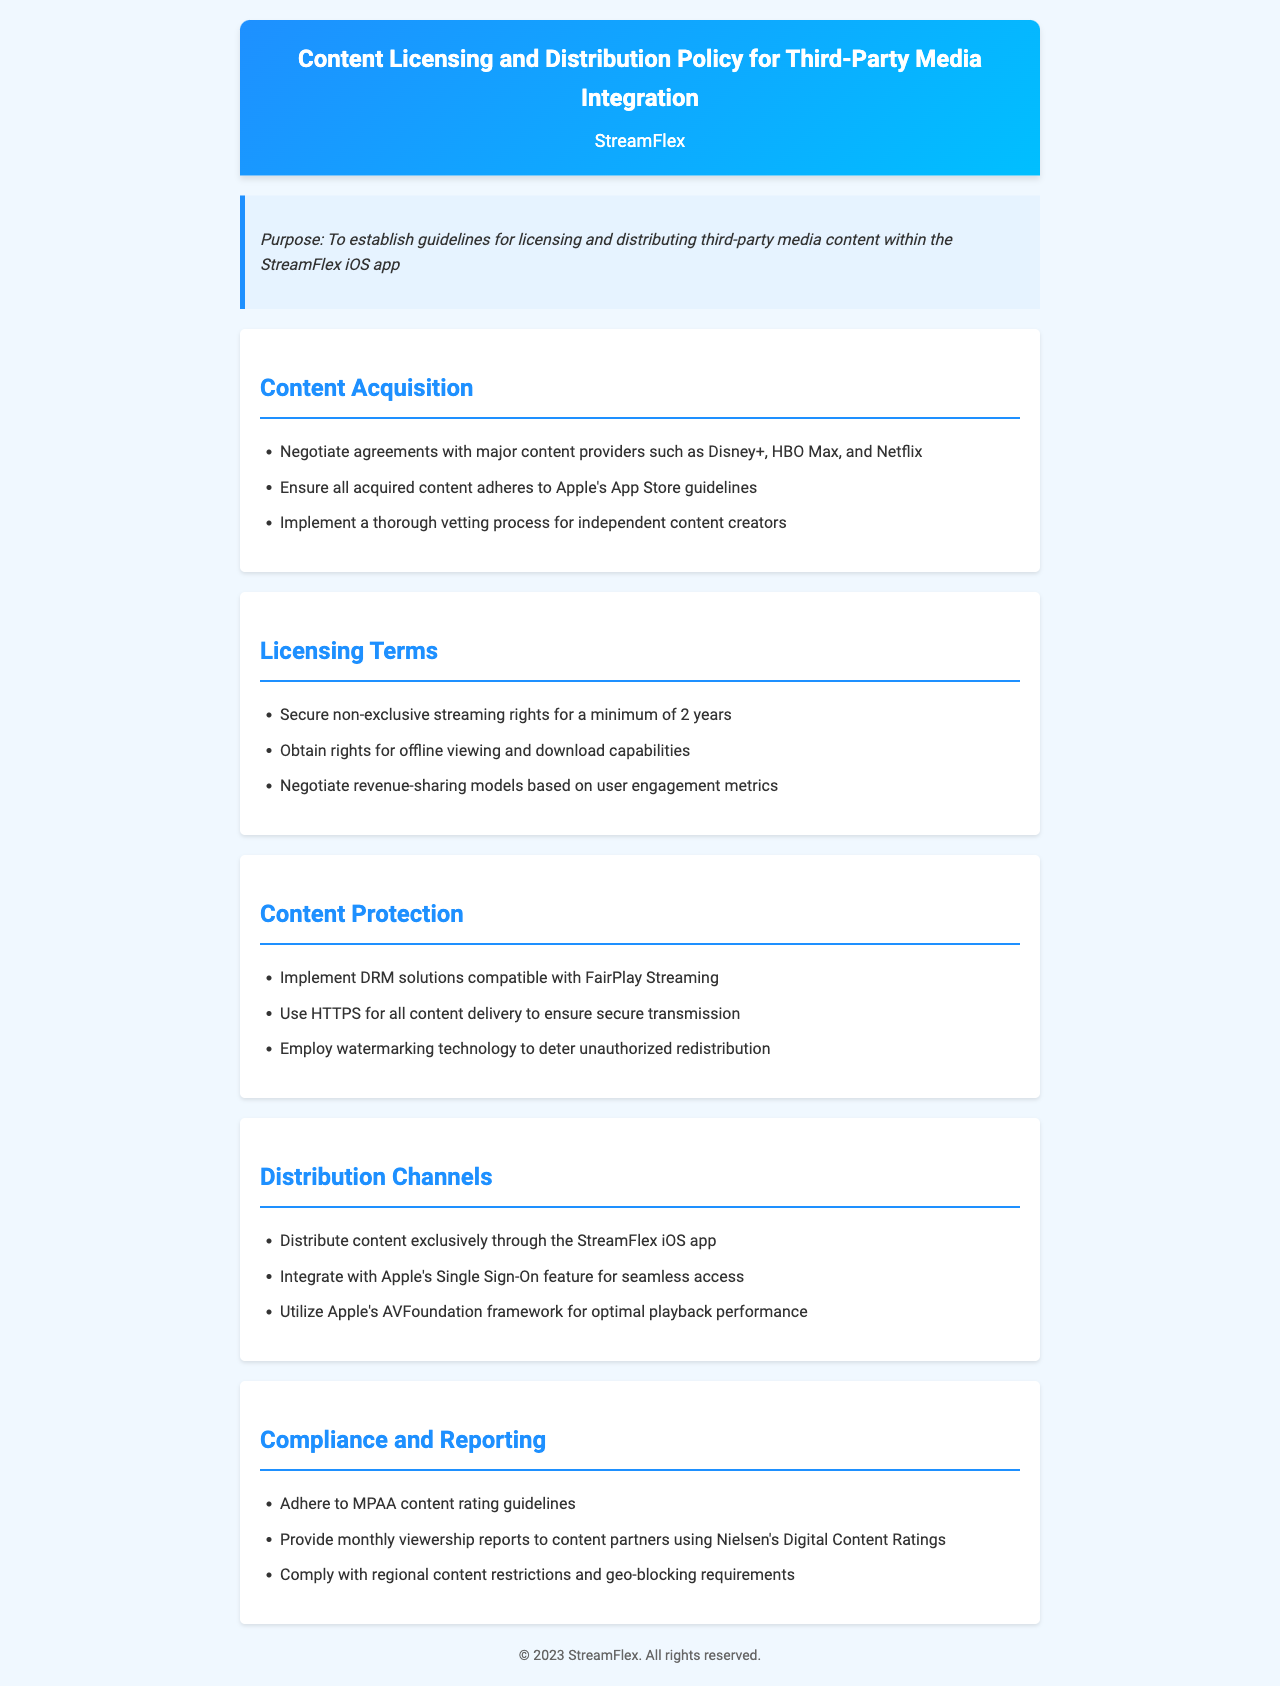What is the purpose of the policy? The purpose of the policy is outlined in the purpose section, which establishes guidelines for licensing and distributing third-party media content within the StreamFlex iOS app.
Answer: To establish guidelines for licensing and distributing third-party media content within the StreamFlex iOS app Which major content providers are mentioned for agreements? The document lists major content providers for agreements in the content acquisition section.
Answer: Disney+, HBO Max, and Netflix What is the minimum duration for secured streaming rights? The licensing terms section specifies the minimum duration for secured streaming rights.
Answer: 2 years What technology is recommended for content protection? The document cites a specific technology for content protection in the content protection section.
Answer: DRM solutions compatible with FairPlay Streaming What is the required distribution channel for content? The distribution section states the only allowed channel for content distribution.
Answer: StreamFlex iOS app Which framework is suggested for optimal playback performance? The document mentions a specific framework for playback performance in the distribution channels section.
Answer: Apple's AVFoundation framework What type of reports must be provided to content partners? The compliance and reporting section specifies the type of reports required for content partners.
Answer: Monthly viewership reports What guidelines must be adhered to regarding content ratings? The compliance section outlines specific guidelines related to content ratings.
Answer: MPAA content rating guidelines What technology is used to deter unauthorized redistribution? The content protection section specifies technology to deter unauthorized redistribution.
Answer: Watermarking technology 